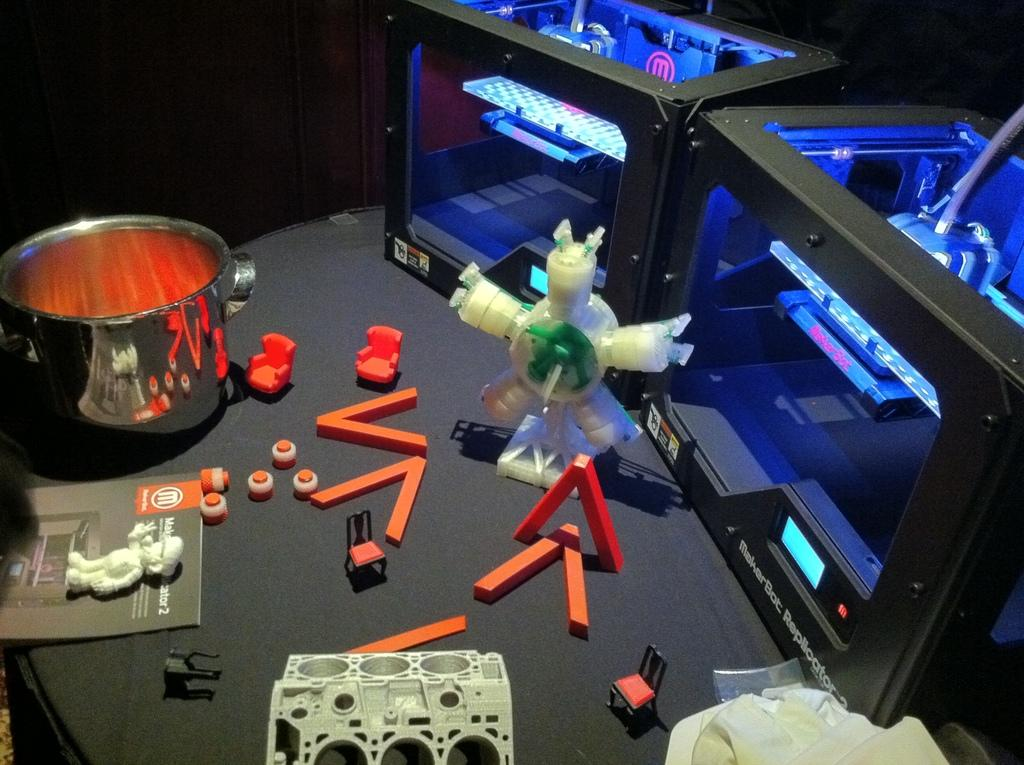What is the primary object in the image? There is a bowl in the image. What else can be seen in the image besides the bowl? There is a book and objects that look like toys in the image. Are there any machines visible in the image? Yes, there are two machines on the table in the image. What type of muscle can be seen flexing in the image? There is no muscle visible in the image; it features a bowl, a book, toys, and machines. 